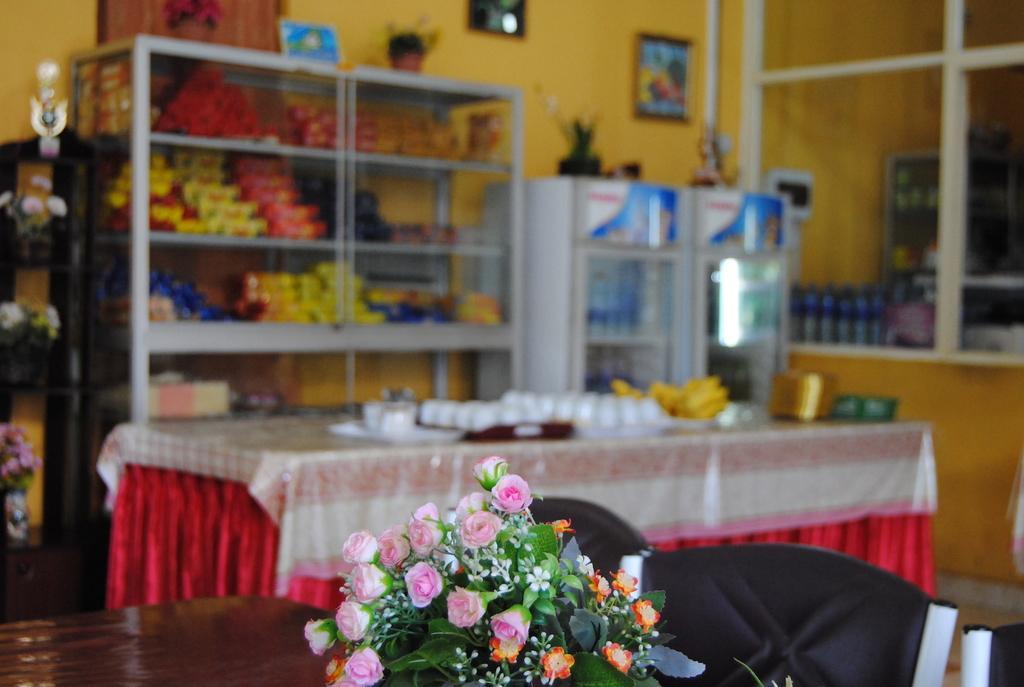Could you give a brief overview of what you see in this image? In this image there are some flowers at bottom of this image and there is a table in middle of this image and there are some objects kept on it. There are some objects are kept in some shelves as we can see in top of this image and there is a wall in the background. There is a window glass at right side of this image. 